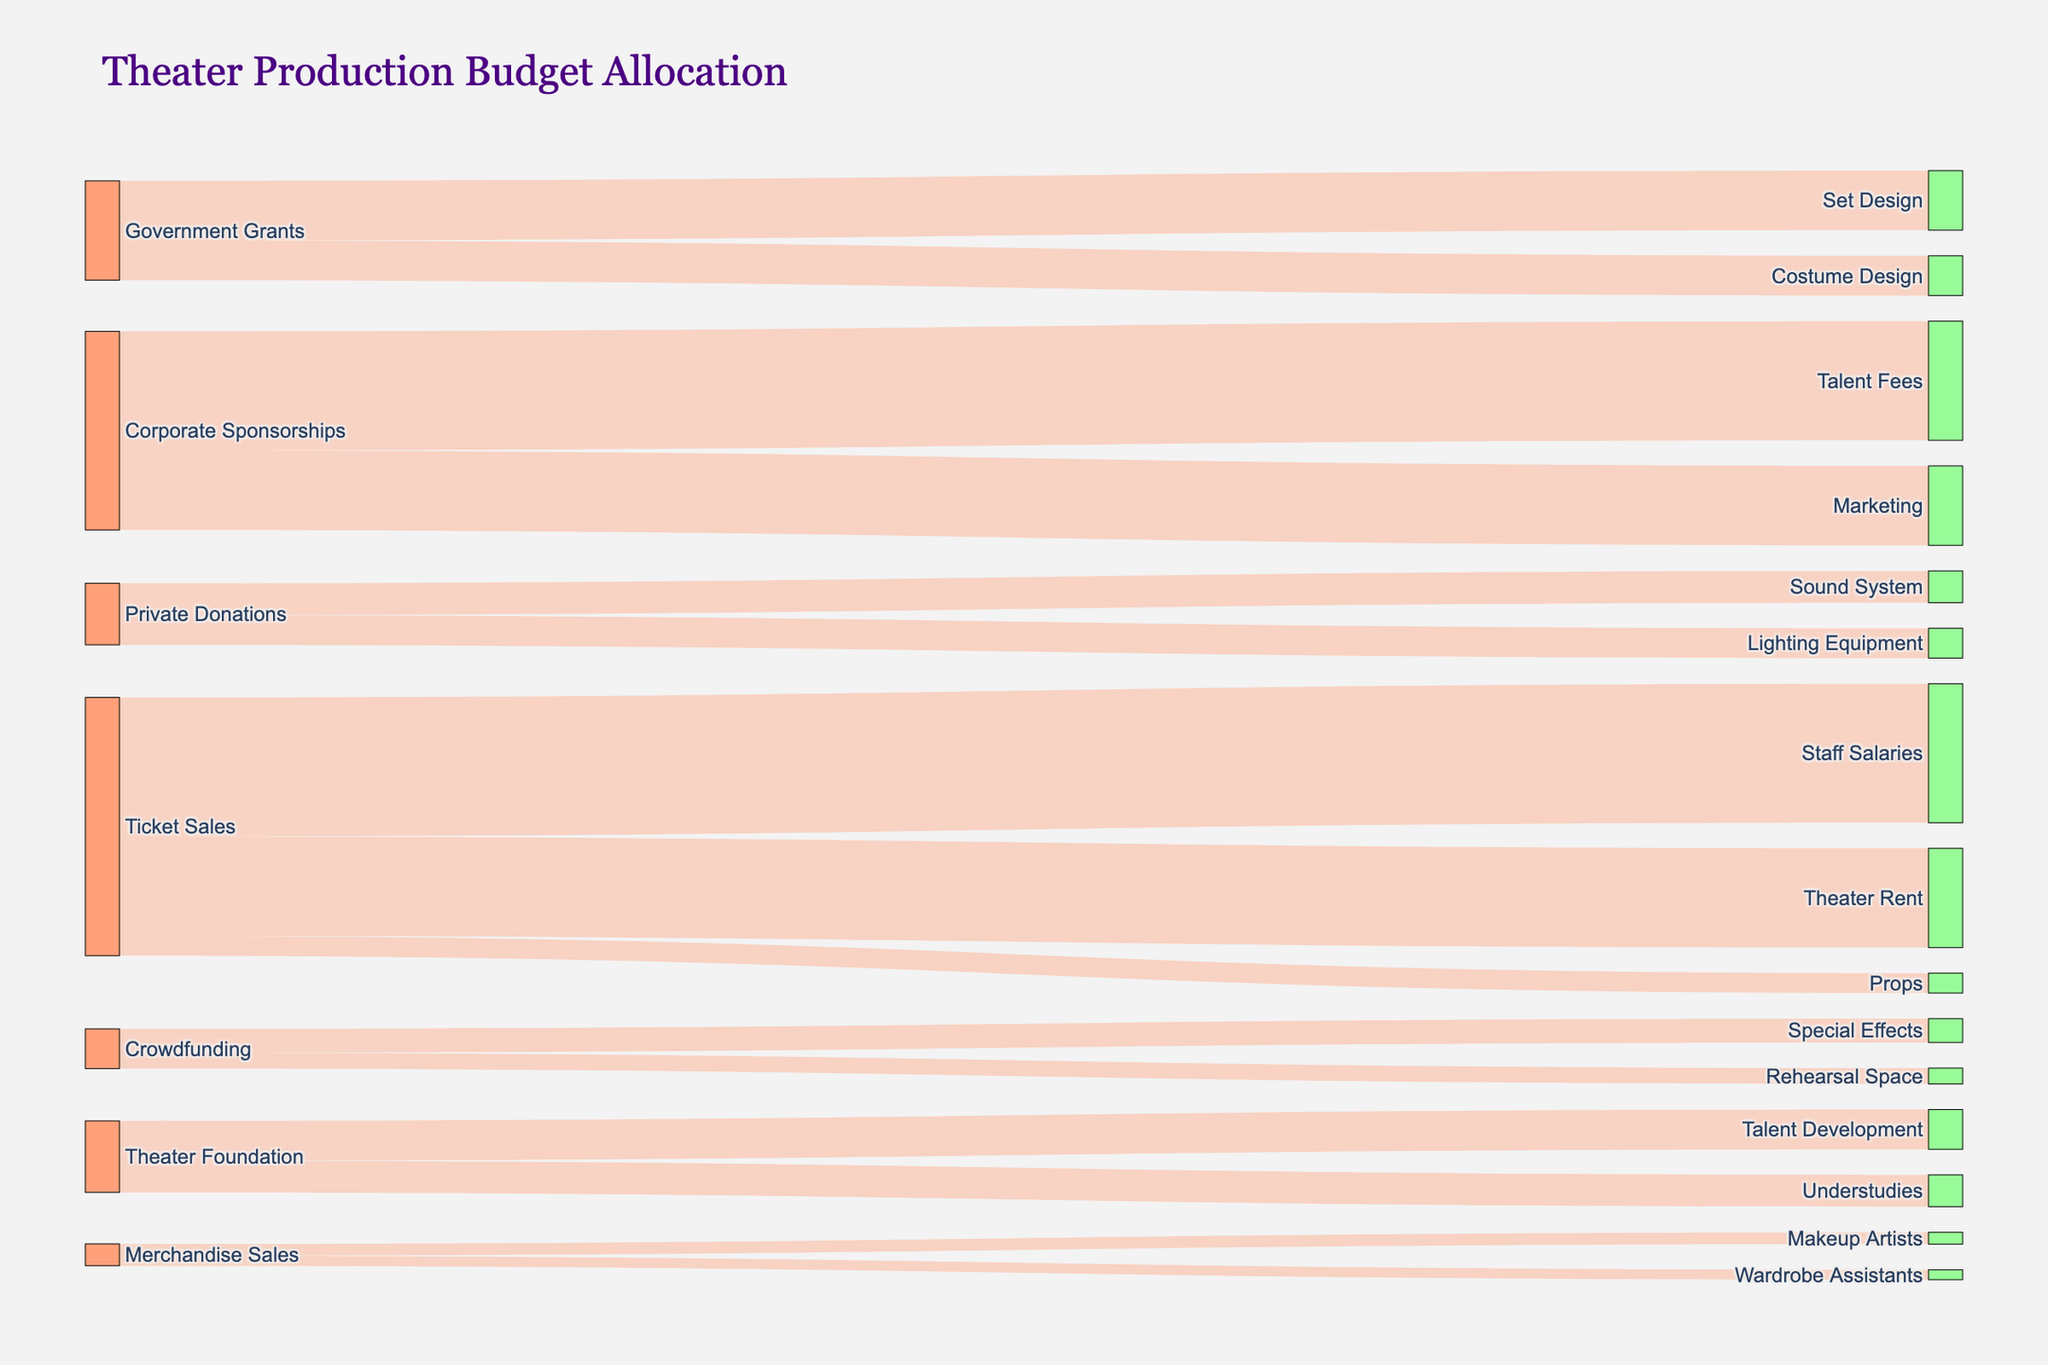Which funding source allocated the most budget to a single expense? To determine the highest single allocation, look at the links and their corresponding values. Corporate Sponsorships allocated 300,000 to Talent Fees, which is the highest individual allocation.
Answer: Corporate Sponsorships to Talent Fees What is the total budget contributed by Ticket Sales? Sum the values of all allocations coming from Ticket Sales: Theater Rent (250,000), Staff Salaries (350,000), and Props (50,000). 250,000 + 350,000 + 50,000 = 650,000.
Answer: 650,000 Which expense category received the least amount of funding? Compare all the values directed towards each expense category. Wardrobe Assistants received 25,000 from Merchandise Sales, which is the smallest value.
Answer: Wardrobe Assistants How does the contribution of Government Grants compare to Private Donations? Sum the allocations for each funding source. Government Grants: Set Design (150,000) + Costume Design (100,000) = 250,000. Private Donations: Lighting Equipment (75,000) + Sound System (80,000) = 155,000. Government Grants allocated more.
Answer: Government Grants allocated more What are the categories funded by Crowdfunding? Check the target categories listed under Crowdfunding as the source. The categories are Special Effects and Rehearsal Space.
Answer: Special Effects, Rehearsal Space What is the highest single expense under Theater Rent? The only funding towards Theater Rent comes from Ticket Sales, with an allocation of 250,000.
Answer: Theater Rent from Ticket Sales How much did Merchandise Sales contribute in total? Sum the values for all allocations from Merchandise Sales: Makeup Artists (30,000) and Wardrobe Assistants (25,000). 30,000 + 25,000 = 55,000.
Answer: 55,000 How is the budget for Talent Development split? The only allocation towards Talent Development is from the Theater Foundation, amounting to 100,000.
Answer: 100,000 Which funding source supports Marketing? The link and color indication show that Marketing is supported by Corporate Sponsorships, with a value of 200,000.
Answer: Corporate Sponsorships What is the total allocation for expenses related to Talent (i.e., Talent Fees, Talent Development, Understudies)? Sum all the values for allocations towards Talent-related expenses: Talent Fees (300,000), Talent Development (100,000), Understudies (80,000). 300,000 + 100,000 + 80,000 = 480,000.
Answer: 480,000 